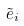<formula> <loc_0><loc_0><loc_500><loc_500>\tilde { e } _ { i }</formula> 